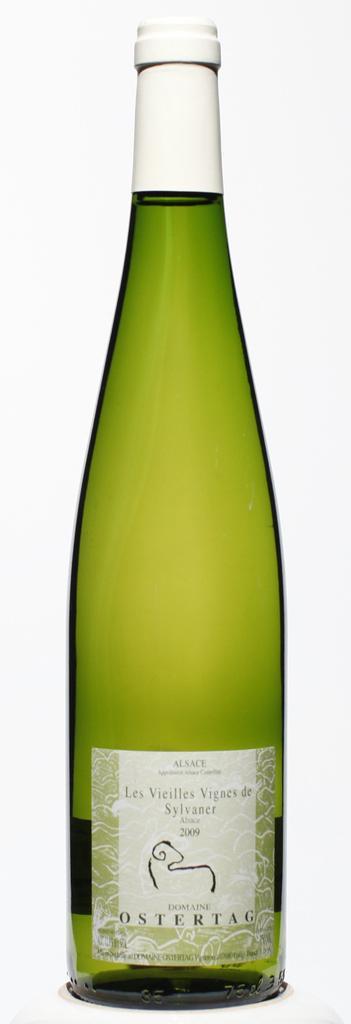In one or two sentences, can you explain what this image depicts? in this image the green bottle is there and the cap is white in color and in front of the bottle some text is there ostertag. 